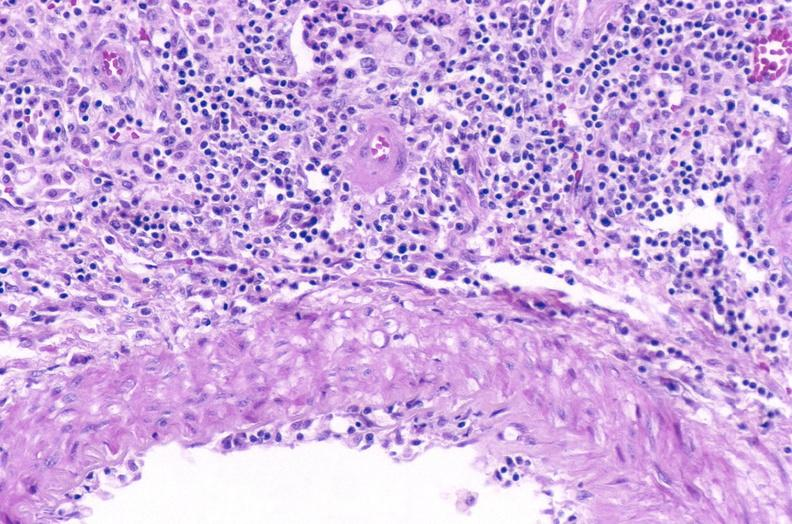does this image show kidney, acute transplant rejection?
Answer the question using a single word or phrase. Yes 